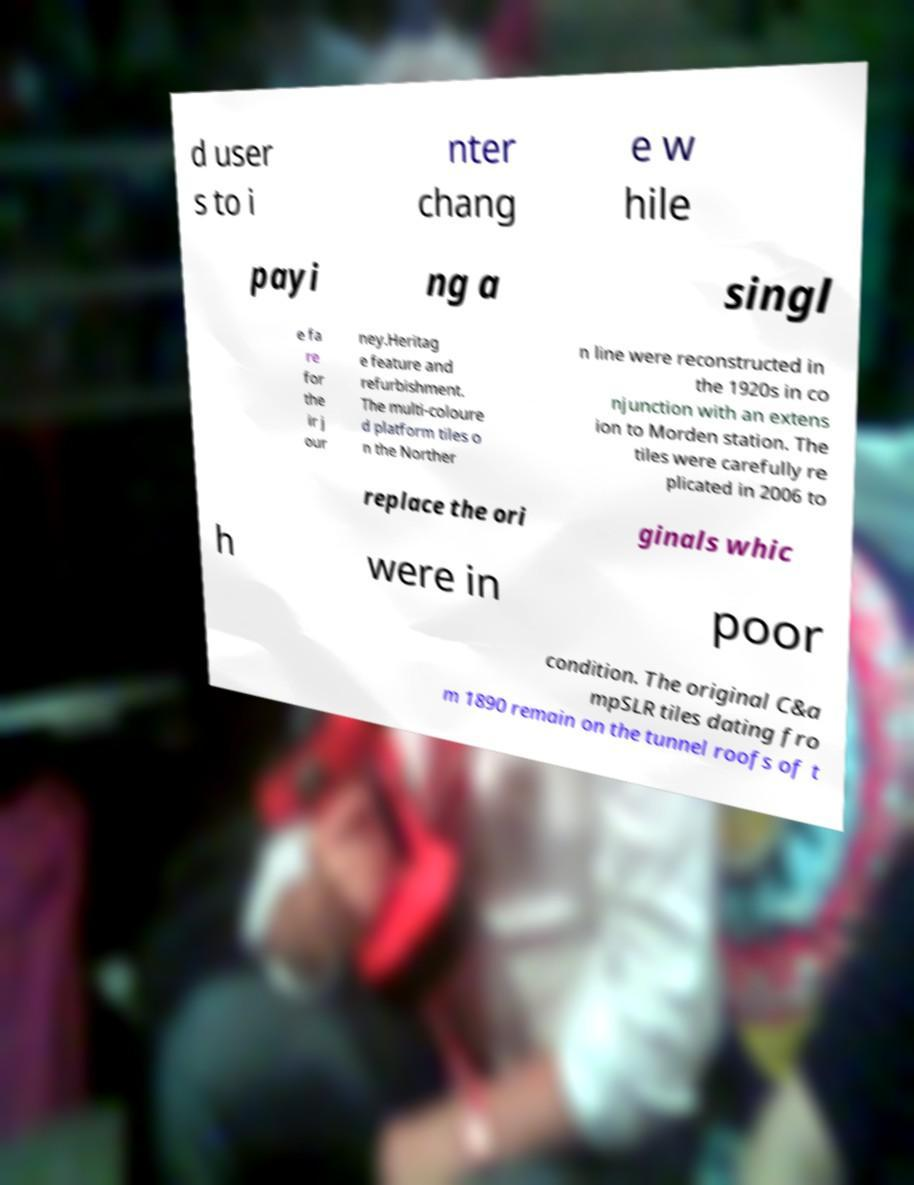Could you assist in decoding the text presented in this image and type it out clearly? d user s to i nter chang e w hile payi ng a singl e fa re for the ir j our ney.Heritag e feature and refurbishment. The multi-coloure d platform tiles o n the Norther n line were reconstructed in the 1920s in co njunction with an extens ion to Morden station. The tiles were carefully re plicated in 2006 to replace the ori ginals whic h were in poor condition. The original C&a mpSLR tiles dating fro m 1890 remain on the tunnel roofs of t 